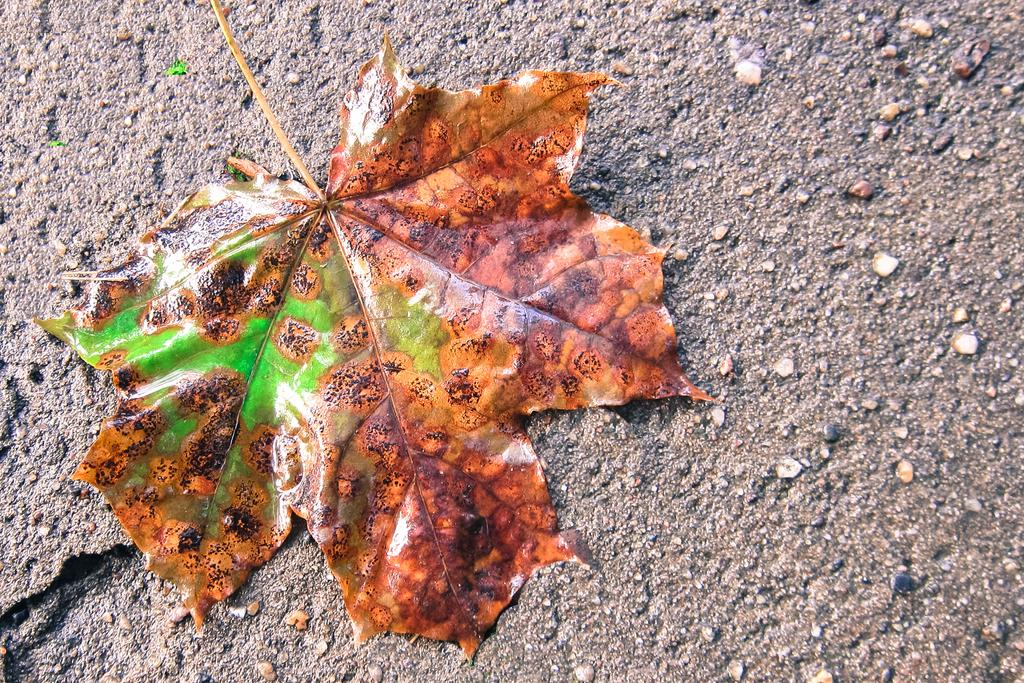What is the color of the leaf in the image? The leaf in the image is brown. What is the condition of the leaf in the image? The leaf is dried in the image. Where is the leaf located in the image? The dried leaf is on the ground in the image. Is there a fire burning near the dried leaf in the image? No, there is no fire present in the image. Can you see a swing in the image? No, there is no swing present in the image. 